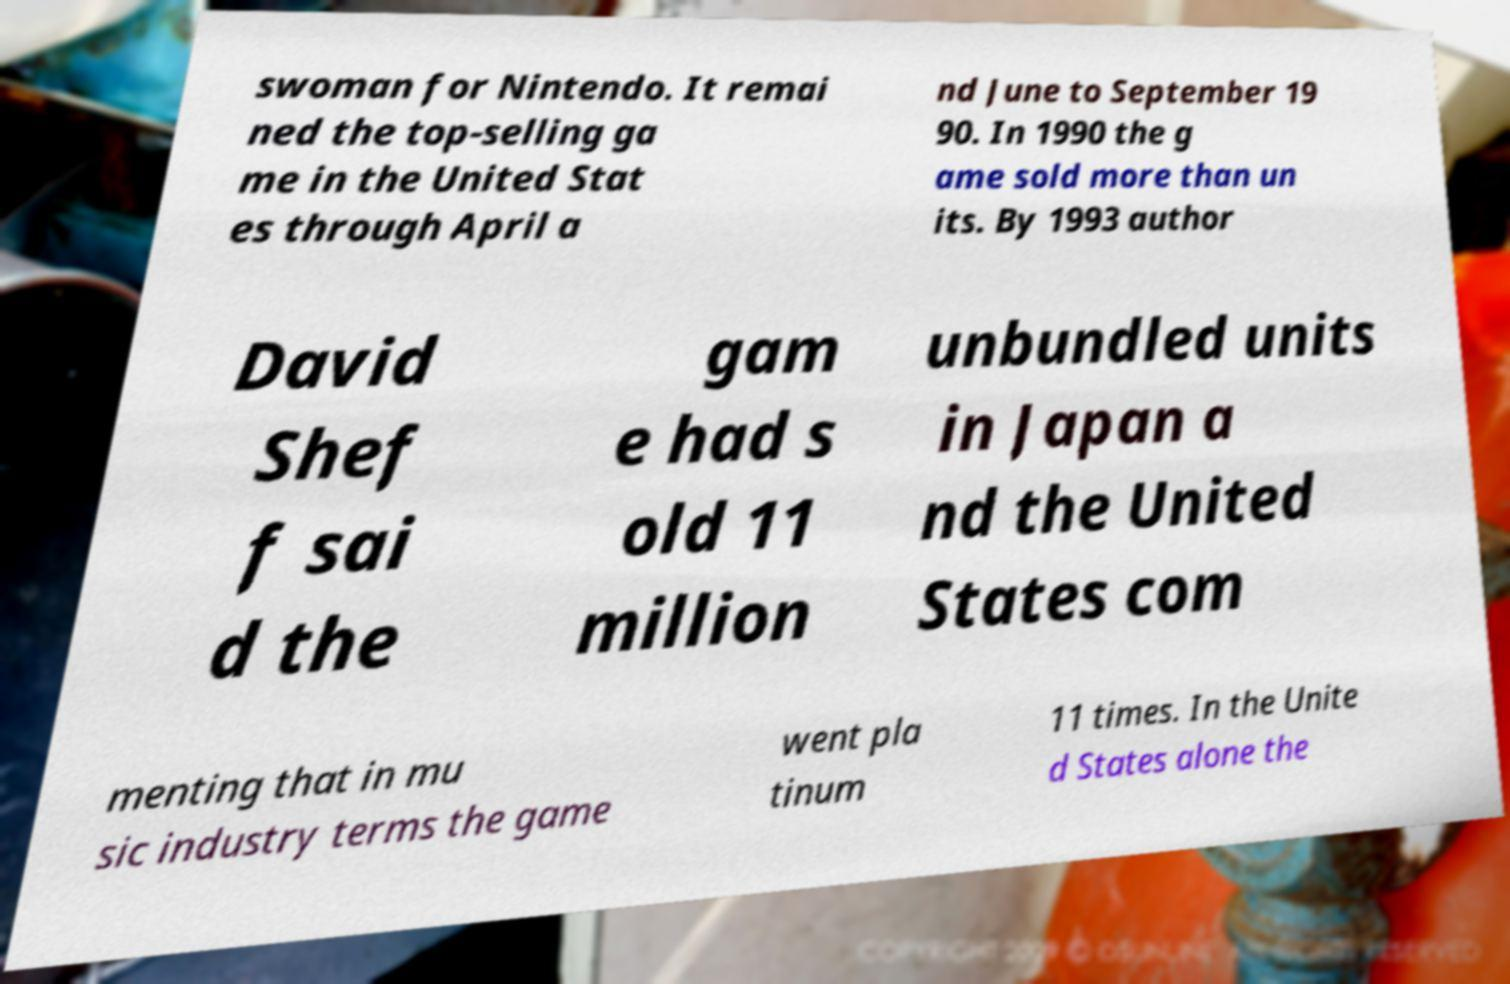Can you accurately transcribe the text from the provided image for me? swoman for Nintendo. It remai ned the top-selling ga me in the United Stat es through April a nd June to September 19 90. In 1990 the g ame sold more than un its. By 1993 author David Shef f sai d the gam e had s old 11 million unbundled units in Japan a nd the United States com menting that in mu sic industry terms the game went pla tinum 11 times. In the Unite d States alone the 